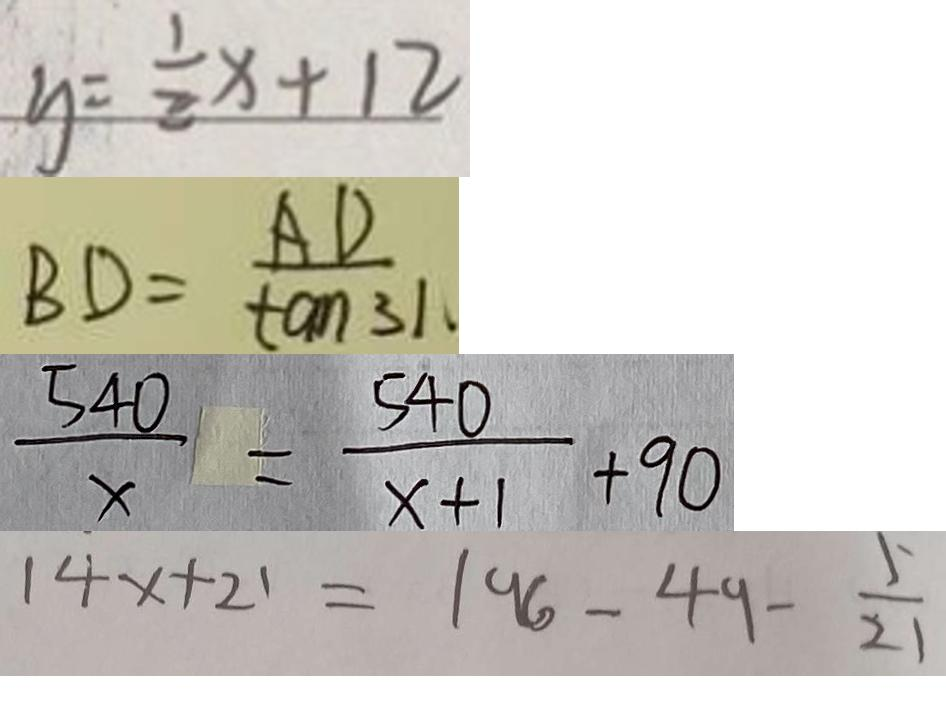Convert formula to latex. <formula><loc_0><loc_0><loc_500><loc_500>y = \frac { 1 } { 2 } x + 1 2 
 B D = \frac { A D } { \tan 3 1 } 
 \frac { 5 4 0 } { x } = \frac { 5 4 0 } { x + 1 } + 9 0 
 1 4 x + 2 1 = 1 9 6 - 4 9 - \frac { 5 } { 2 1 }</formula> 